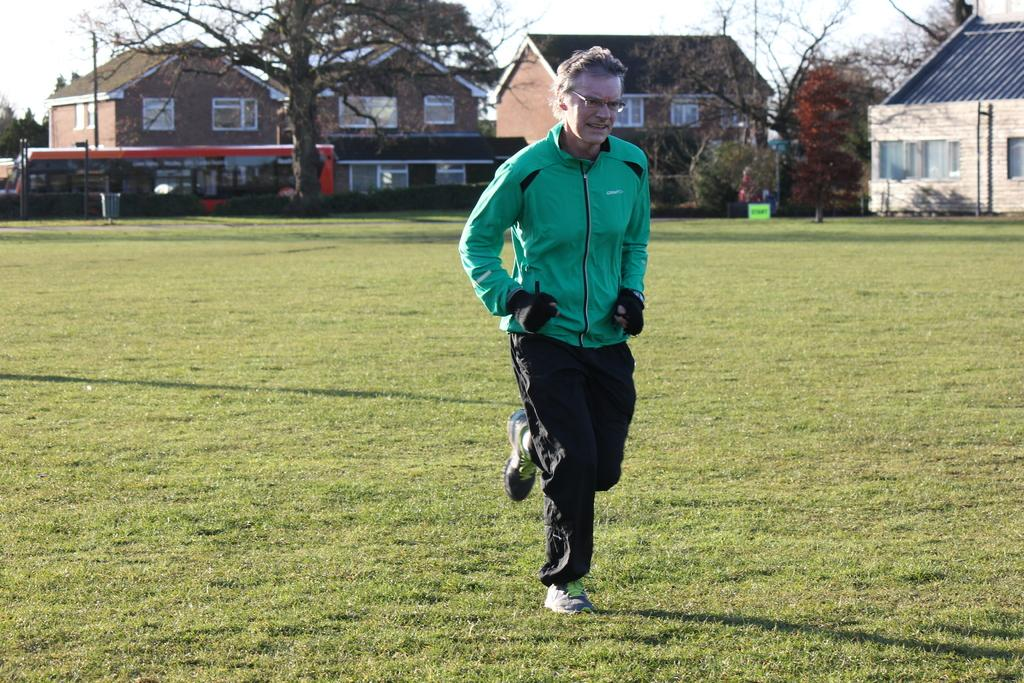What is the man in the image doing? The man is jogging in the image. Where is the man jogging? The man is jogging in a ground. What can be seen in the background of the image? There are trees, a bus, houses, and the sky visible in the background of the image. What type of polish is the man applying to the lumber in the image? There is no polish or lumber present in the image; the man is jogging in a ground with trees, a bus, houses, and the sky visible in the background. What is the man doing with the gate in the image? There is no gate present in the image; the man is jogging in a ground with trees, a bus, houses, and the sky visible in the background. 